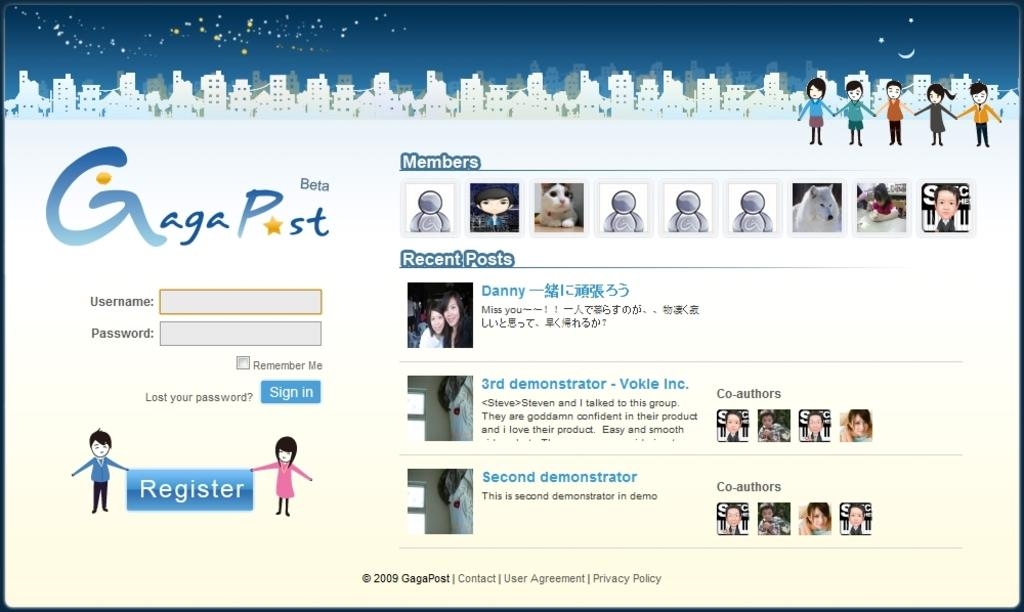What type of content is shown in the image? The image contains a web page. What can be seen on the web page? There are people, buildings, a dog, symbols, and text depicted on the web page. Where is the flower located in the image? There is no flower present in the image; it only contains a web page with the mentioned elements. 